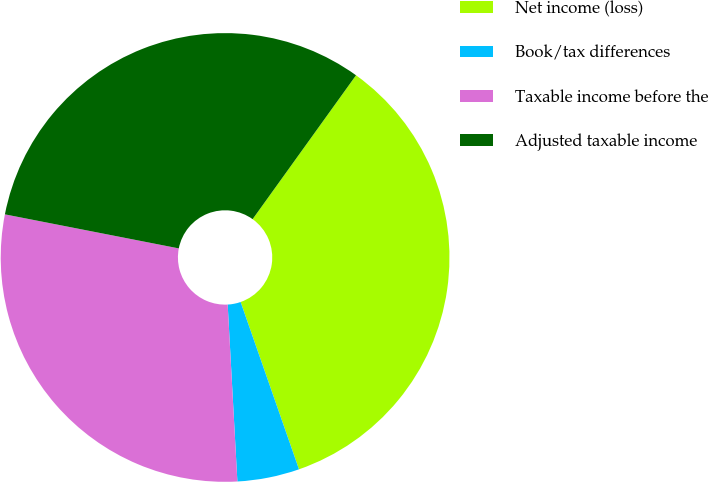Convert chart. <chart><loc_0><loc_0><loc_500><loc_500><pie_chart><fcel>Net income (loss)<fcel>Book/tax differences<fcel>Taxable income before the<fcel>Adjusted taxable income<nl><fcel>34.74%<fcel>4.47%<fcel>28.95%<fcel>31.84%<nl></chart> 